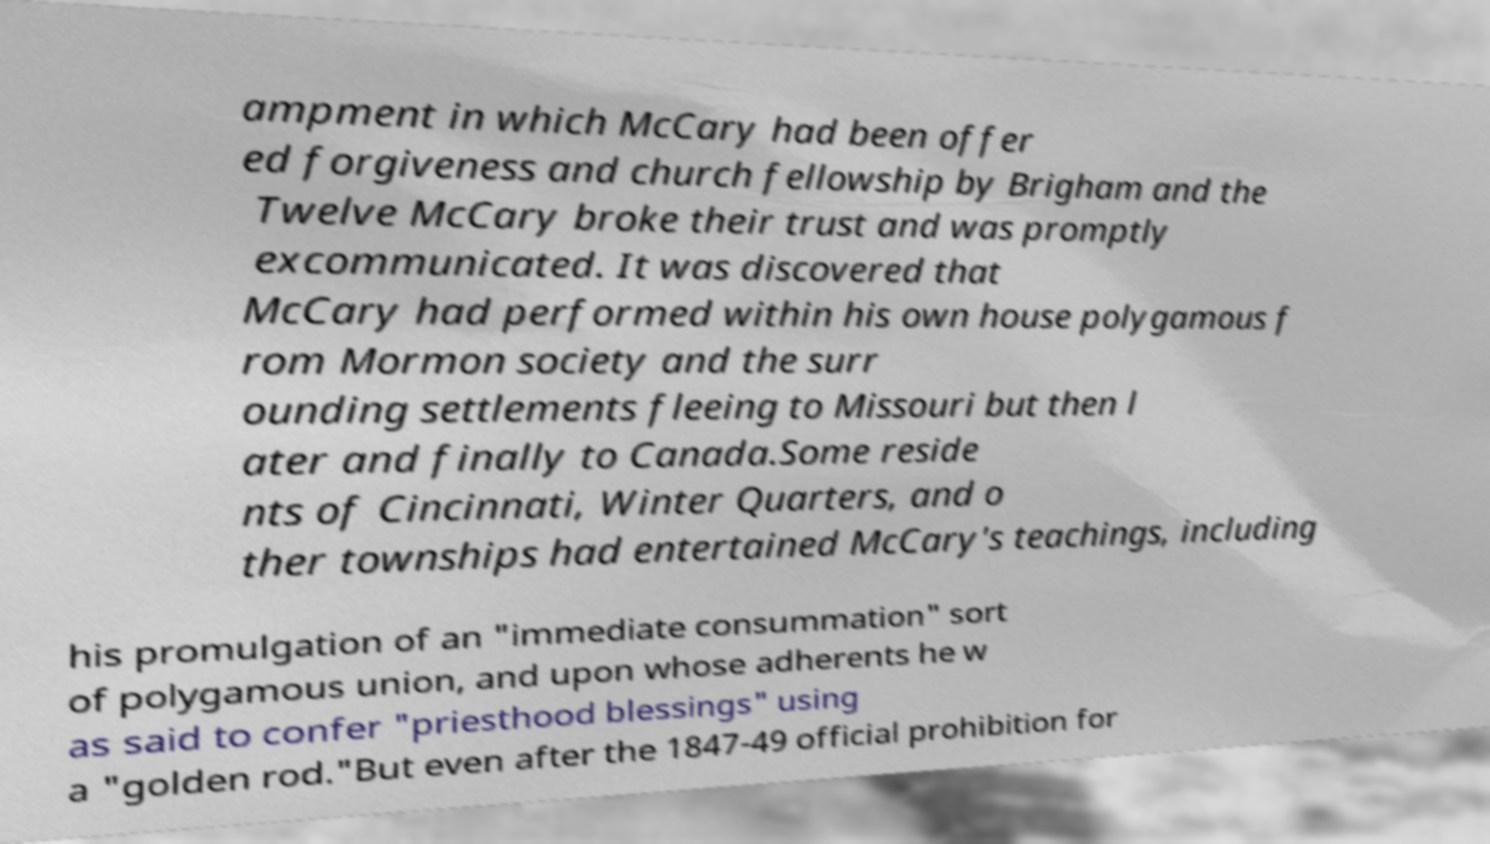Can you read and provide the text displayed in the image?This photo seems to have some interesting text. Can you extract and type it out for me? ampment in which McCary had been offer ed forgiveness and church fellowship by Brigham and the Twelve McCary broke their trust and was promptly excommunicated. It was discovered that McCary had performed within his own house polygamous f rom Mormon society and the surr ounding settlements fleeing to Missouri but then l ater and finally to Canada.Some reside nts of Cincinnati, Winter Quarters, and o ther townships had entertained McCary's teachings, including his promulgation of an "immediate consummation" sort of polygamous union, and upon whose adherents he w as said to confer "priesthood blessings" using a "golden rod."But even after the 1847-49 official prohibition for 